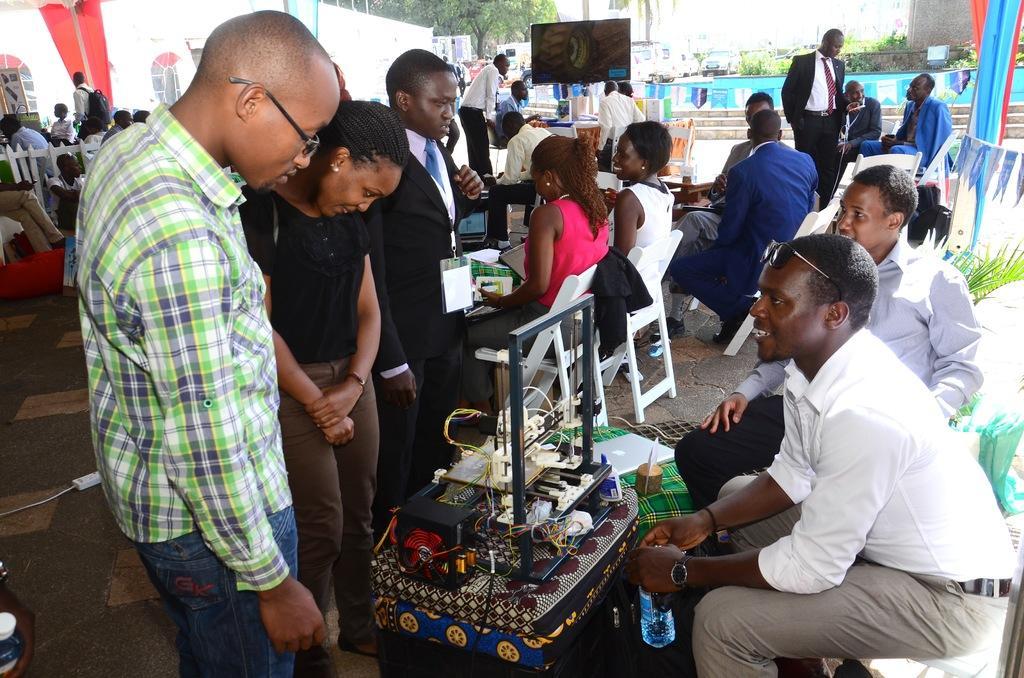Please provide a concise description of this image. In this picture I can see there are two men sitting at the right side and there is an equipment and a few people standing at the left side. There are a few more people in the backdrop among them few are standing and few are standing. There are few plants, vehicles parked. 